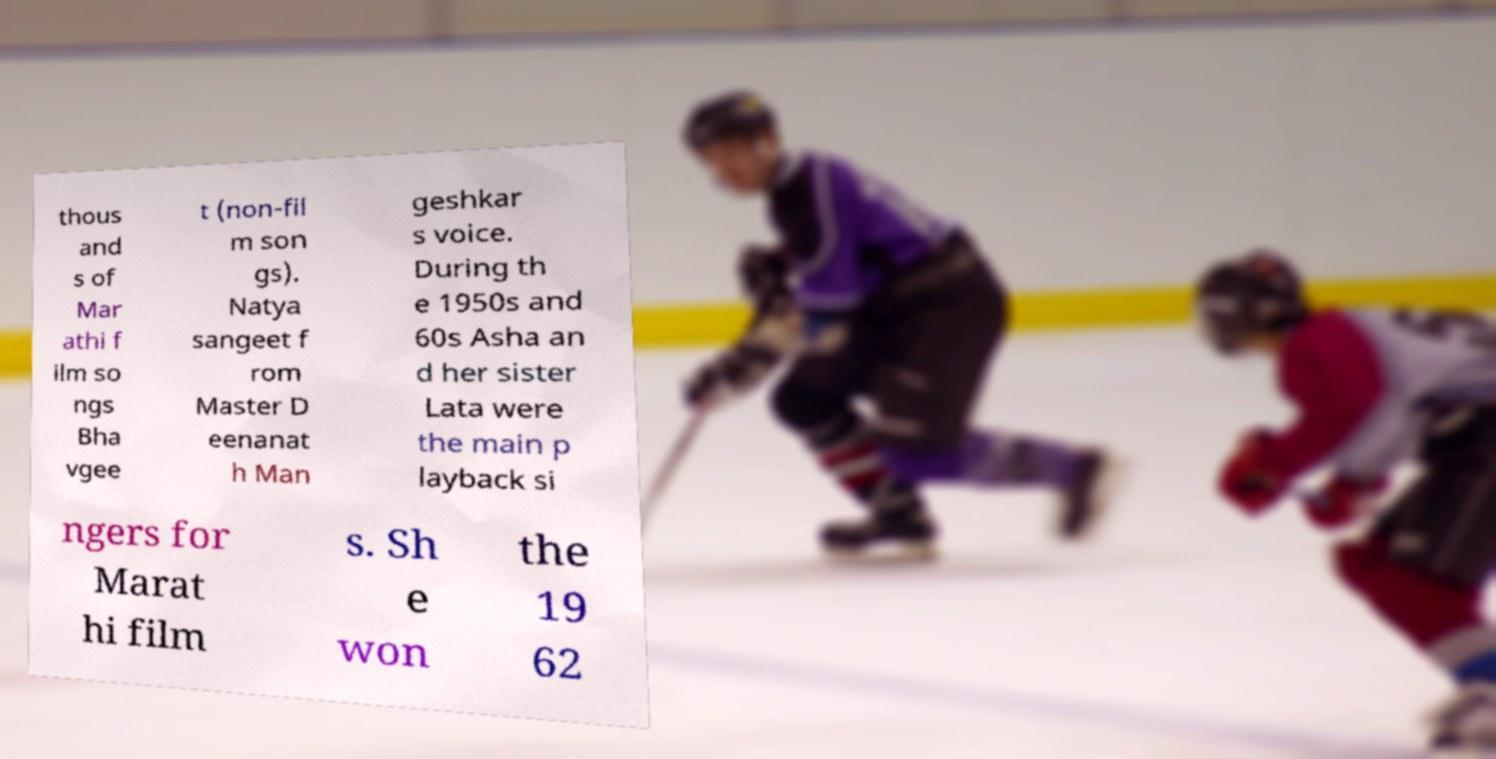There's text embedded in this image that I need extracted. Can you transcribe it verbatim? thous and s of Mar athi f ilm so ngs Bha vgee t (non-fil m son gs). Natya sangeet f rom Master D eenanat h Man geshkar s voice. During th e 1950s and 60s Asha an d her sister Lata were the main p layback si ngers for Marat hi film s. Sh e won the 19 62 